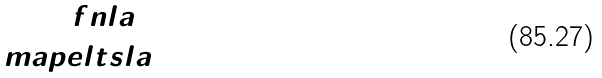<formula> <loc_0><loc_0><loc_500><loc_500>\ f n l a { 1 } { 2 } { 3 } \\ \ m a p e l t s l a { 4 } { 5 }</formula> 